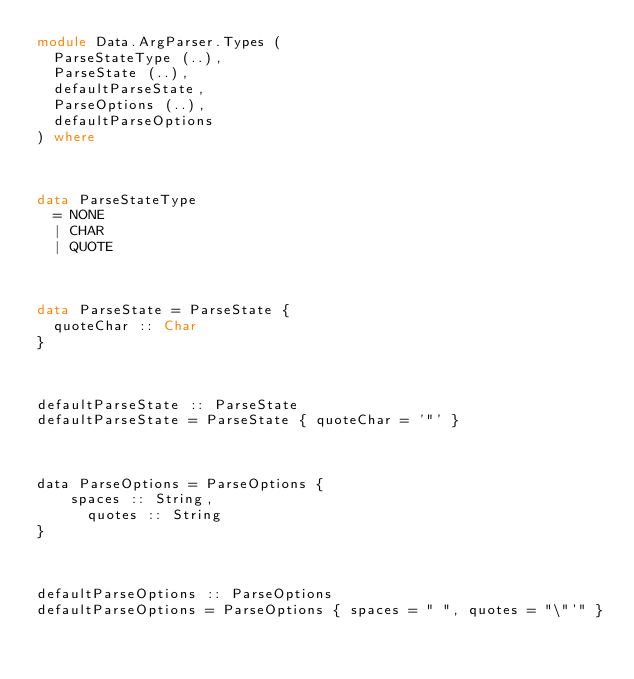Convert code to text. <code><loc_0><loc_0><loc_500><loc_500><_Haskell_>module Data.ArgParser.Types (
  ParseStateType (..),
  ParseState (..),
  defaultParseState,
  ParseOptions (..),
  defaultParseOptions
) where



data ParseStateType
  = NONE
  | CHAR
  | QUOTE



data ParseState = ParseState {
  quoteChar :: Char
}



defaultParseState :: ParseState
defaultParseState = ParseState { quoteChar = '"' }



data ParseOptions = ParseOptions {
    spaces :: String,
      quotes :: String
}



defaultParseOptions :: ParseOptions
defaultParseOptions = ParseOptions { spaces = " ", quotes = "\"'" }
</code> 